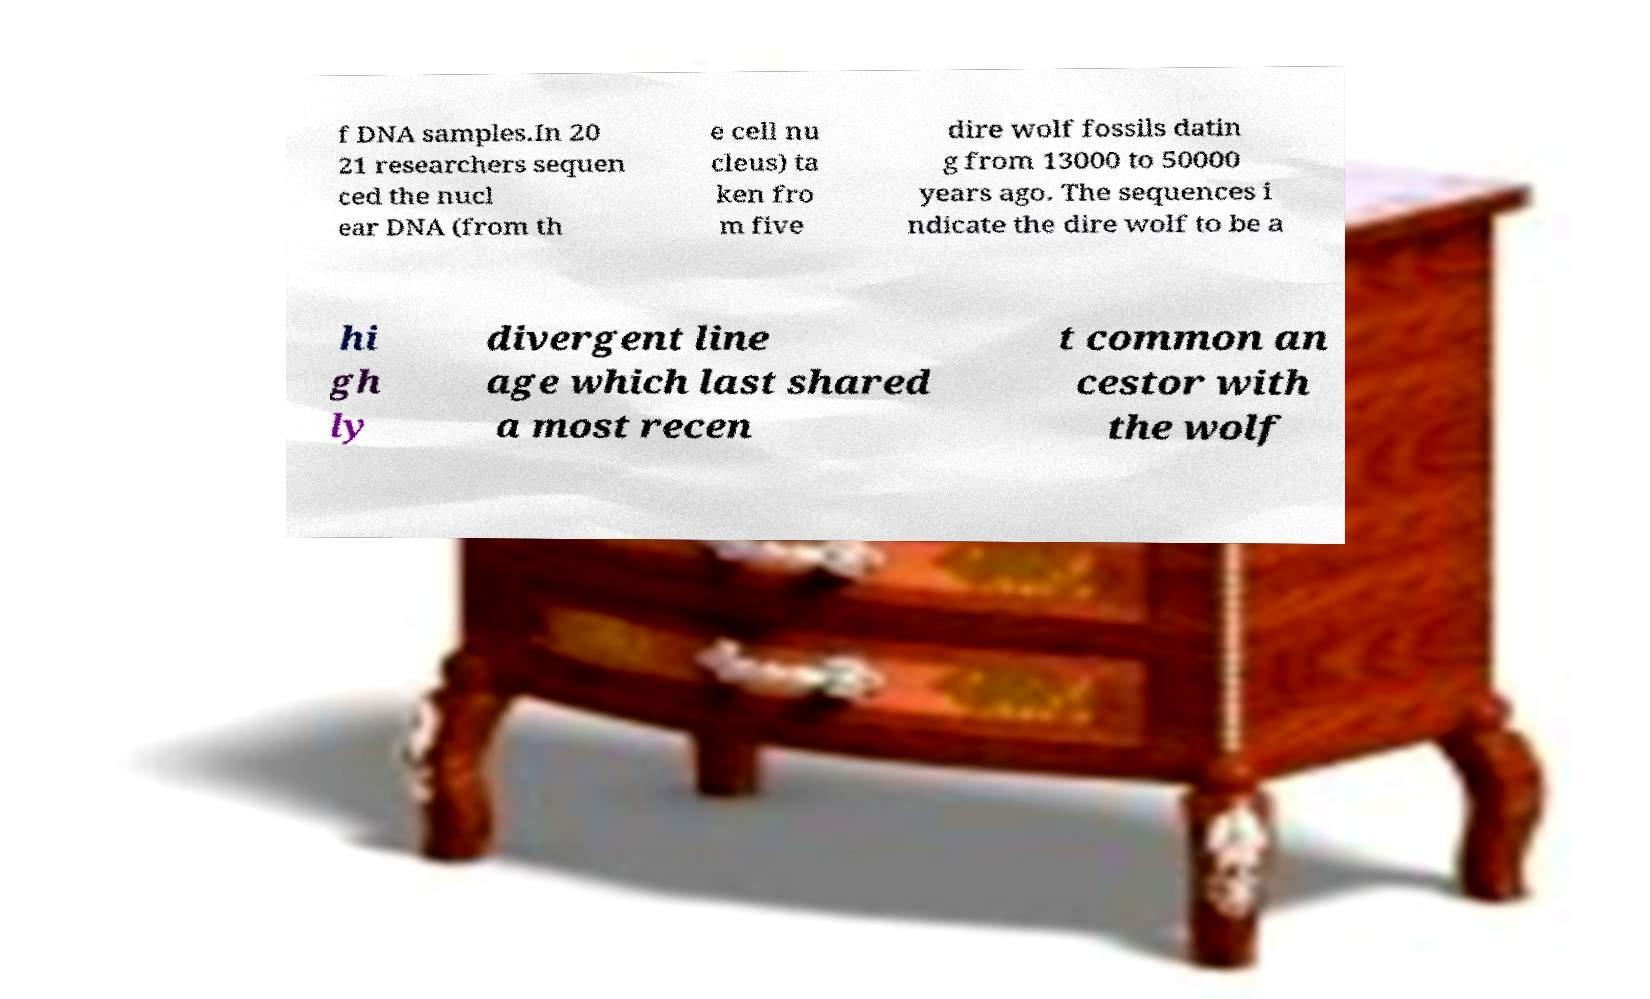I need the written content from this picture converted into text. Can you do that? f DNA samples.In 20 21 researchers sequen ced the nucl ear DNA (from th e cell nu cleus) ta ken fro m five dire wolf fossils datin g from 13000 to 50000 years ago. The sequences i ndicate the dire wolf to be a hi gh ly divergent line age which last shared a most recen t common an cestor with the wolf 